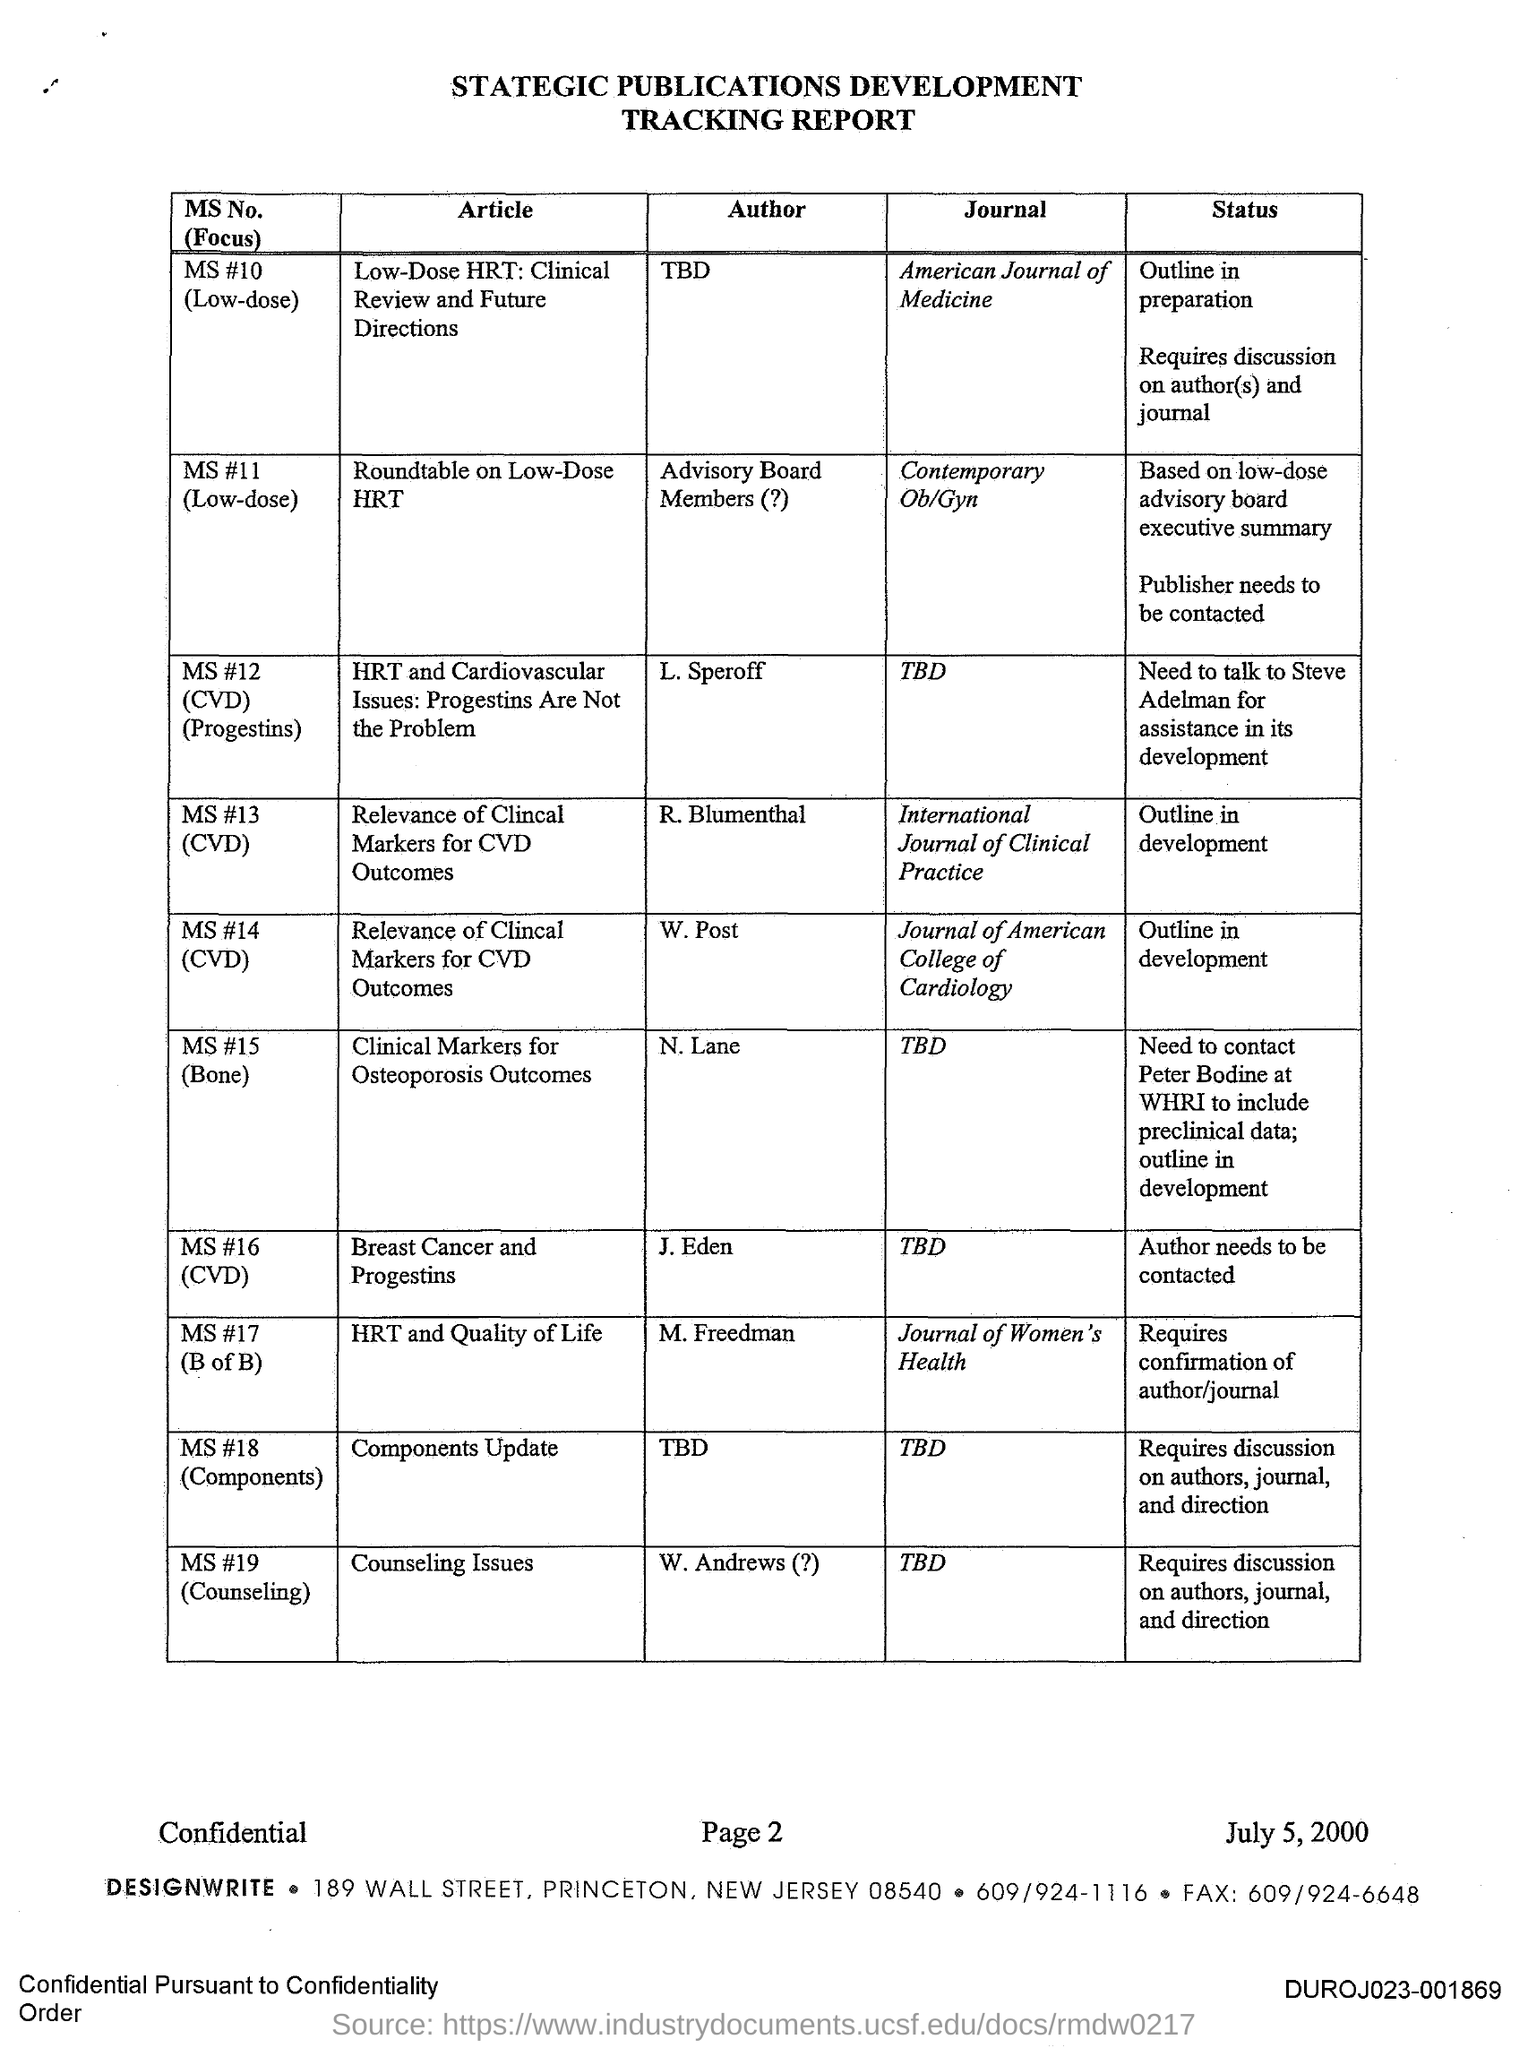What can you infer about DesignWrite based on this document? DesignWrite seems to be an organization that specializes in the development and management of scientific publications, as suggested by the document's detailed records of manuscript statuses and the next steps required for their development. The tracking report demonstrates a strategic approach to the publication process across various scientific journals, possibly indicating that DesignWrite operates in medical communications and publishing consultancy. 